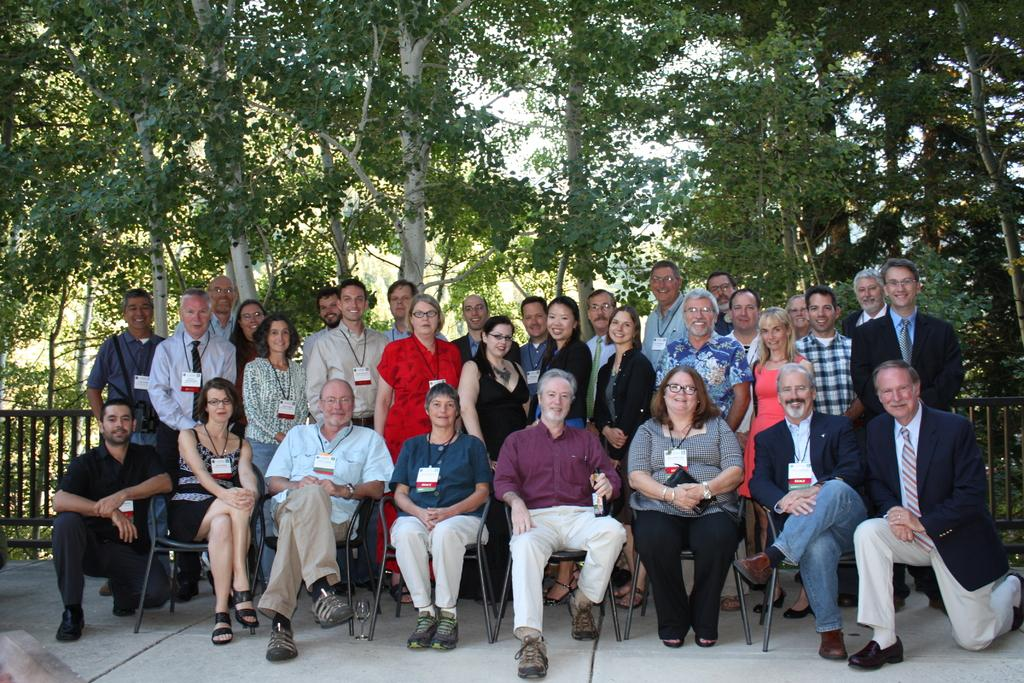How many people are in the image? There is a group of people in the image, but the exact number is not specified. What are some of the people in the image doing? Some people are sitting on chairs, while others are standing. What can be seen in the background of the image? There is a fence and trees visible in the background. What type of event is being suggested by the people in the image? There is no indication of an event being suggested or discussed in the image. 